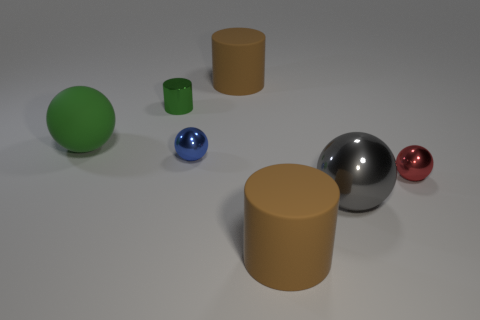There is a metal cylinder that is the same color as the matte ball; what size is it?
Offer a terse response. Small. Are there any other things that have the same color as the metal cylinder?
Your response must be concise. Yes. There is a large object that is on the left side of the metal object that is behind the blue metal thing; what is its material?
Ensure brevity in your answer.  Rubber. Does the tiny red ball have the same material as the big thing to the left of the small green metallic thing?
Give a very brief answer. No. How many objects are either large brown rubber things in front of the tiny blue ball or tiny cyan metal things?
Provide a short and direct response. 1. Are there any shiny things of the same color as the large rubber sphere?
Provide a succinct answer. Yes. There is a tiny green thing; does it have the same shape as the big brown rubber thing that is behind the green matte thing?
Your answer should be compact. Yes. How many things are in front of the tiny blue thing and behind the gray metallic thing?
Provide a short and direct response. 1. What material is the big green object that is the same shape as the tiny blue thing?
Ensure brevity in your answer.  Rubber. How big is the brown thing behind the big brown rubber thing that is in front of the red metal sphere?
Keep it short and to the point. Large. 